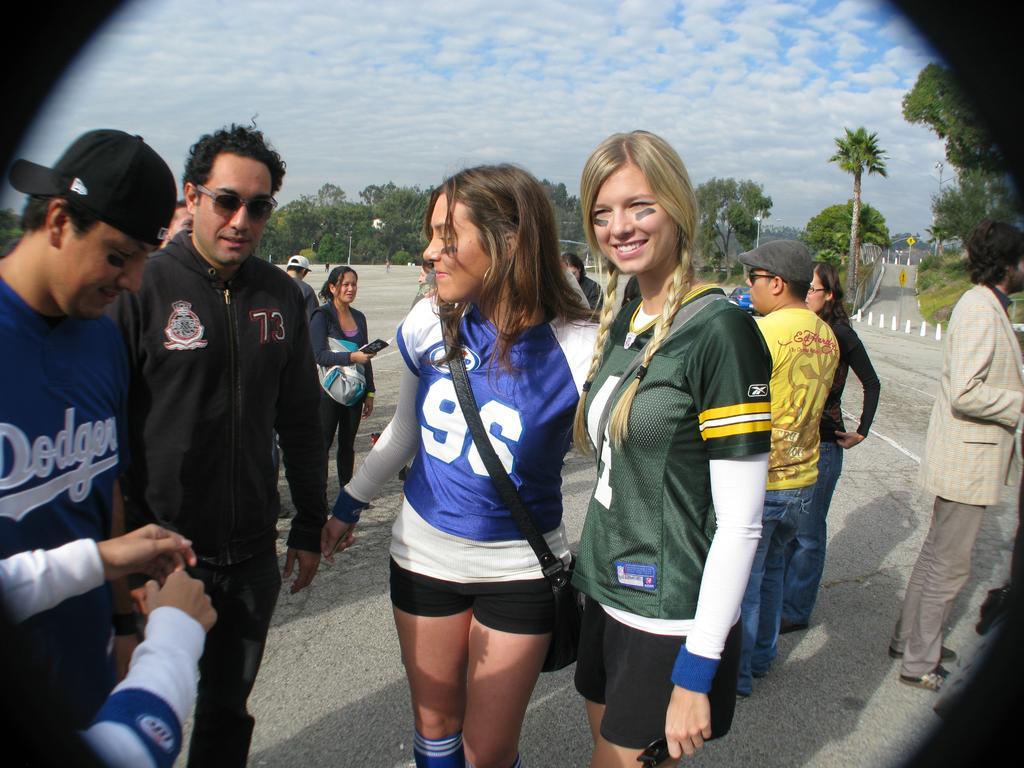In one or two sentences, can you explain what this image depicts? In this image I can see number of people are standing. I can see smile on few faces and I can see two of them are wearing caps. In the background I can see number of trees, clouds and the sky. 